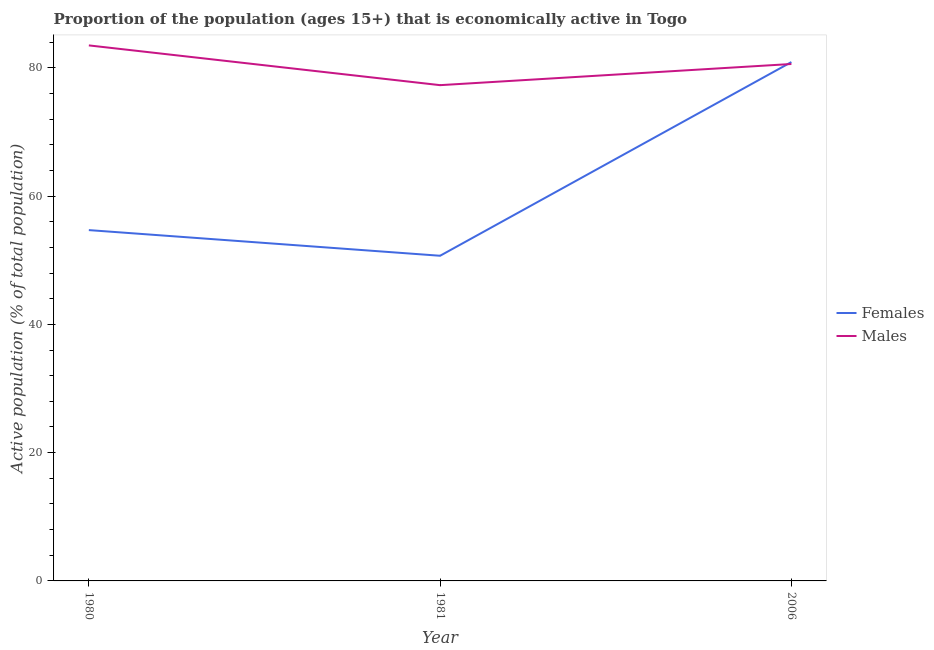Does the line corresponding to percentage of economically active male population intersect with the line corresponding to percentage of economically active female population?
Offer a very short reply. Yes. What is the percentage of economically active female population in 1980?
Your answer should be very brief. 54.7. Across all years, what is the maximum percentage of economically active male population?
Give a very brief answer. 83.5. Across all years, what is the minimum percentage of economically active male population?
Your answer should be compact. 77.3. In which year was the percentage of economically active female population maximum?
Give a very brief answer. 2006. What is the total percentage of economically active male population in the graph?
Your answer should be very brief. 241.4. What is the difference between the percentage of economically active female population in 1980 and the percentage of economically active male population in 1981?
Offer a very short reply. -22.6. What is the average percentage of economically active male population per year?
Keep it short and to the point. 80.47. In the year 1980, what is the difference between the percentage of economically active male population and percentage of economically active female population?
Offer a terse response. 28.8. What is the ratio of the percentage of economically active female population in 1980 to that in 1981?
Keep it short and to the point. 1.08. Is the percentage of economically active female population in 1980 less than that in 1981?
Provide a short and direct response. No. What is the difference between the highest and the second highest percentage of economically active female population?
Ensure brevity in your answer.  26.2. What is the difference between the highest and the lowest percentage of economically active female population?
Provide a succinct answer. 30.2. Is the percentage of economically active female population strictly less than the percentage of economically active male population over the years?
Keep it short and to the point. No. How many lines are there?
Give a very brief answer. 2. How many years are there in the graph?
Give a very brief answer. 3. Where does the legend appear in the graph?
Ensure brevity in your answer.  Center right. How many legend labels are there?
Your answer should be compact. 2. What is the title of the graph?
Your response must be concise. Proportion of the population (ages 15+) that is economically active in Togo. Does "Largest city" appear as one of the legend labels in the graph?
Offer a terse response. No. What is the label or title of the X-axis?
Provide a short and direct response. Year. What is the label or title of the Y-axis?
Provide a succinct answer. Active population (% of total population). What is the Active population (% of total population) of Females in 1980?
Make the answer very short. 54.7. What is the Active population (% of total population) in Males in 1980?
Offer a very short reply. 83.5. What is the Active population (% of total population) in Females in 1981?
Keep it short and to the point. 50.7. What is the Active population (% of total population) of Males in 1981?
Keep it short and to the point. 77.3. What is the Active population (% of total population) in Females in 2006?
Offer a terse response. 80.9. What is the Active population (% of total population) of Males in 2006?
Provide a short and direct response. 80.6. Across all years, what is the maximum Active population (% of total population) of Females?
Your answer should be very brief. 80.9. Across all years, what is the maximum Active population (% of total population) in Males?
Your answer should be very brief. 83.5. Across all years, what is the minimum Active population (% of total population) in Females?
Provide a succinct answer. 50.7. Across all years, what is the minimum Active population (% of total population) of Males?
Keep it short and to the point. 77.3. What is the total Active population (% of total population) of Females in the graph?
Make the answer very short. 186.3. What is the total Active population (% of total population) of Males in the graph?
Offer a terse response. 241.4. What is the difference between the Active population (% of total population) of Females in 1980 and that in 1981?
Keep it short and to the point. 4. What is the difference between the Active population (% of total population) in Males in 1980 and that in 1981?
Your response must be concise. 6.2. What is the difference between the Active population (% of total population) of Females in 1980 and that in 2006?
Ensure brevity in your answer.  -26.2. What is the difference between the Active population (% of total population) in Females in 1981 and that in 2006?
Offer a terse response. -30.2. What is the difference between the Active population (% of total population) in Females in 1980 and the Active population (% of total population) in Males in 1981?
Offer a very short reply. -22.6. What is the difference between the Active population (% of total population) of Females in 1980 and the Active population (% of total population) of Males in 2006?
Provide a short and direct response. -25.9. What is the difference between the Active population (% of total population) in Females in 1981 and the Active population (% of total population) in Males in 2006?
Your answer should be very brief. -29.9. What is the average Active population (% of total population) in Females per year?
Provide a succinct answer. 62.1. What is the average Active population (% of total population) of Males per year?
Offer a very short reply. 80.47. In the year 1980, what is the difference between the Active population (% of total population) in Females and Active population (% of total population) in Males?
Offer a terse response. -28.8. In the year 1981, what is the difference between the Active population (% of total population) of Females and Active population (% of total population) of Males?
Your response must be concise. -26.6. In the year 2006, what is the difference between the Active population (% of total population) of Females and Active population (% of total population) of Males?
Give a very brief answer. 0.3. What is the ratio of the Active population (% of total population) in Females in 1980 to that in 1981?
Your answer should be compact. 1.08. What is the ratio of the Active population (% of total population) in Males in 1980 to that in 1981?
Ensure brevity in your answer.  1.08. What is the ratio of the Active population (% of total population) in Females in 1980 to that in 2006?
Your answer should be very brief. 0.68. What is the ratio of the Active population (% of total population) in Males in 1980 to that in 2006?
Provide a short and direct response. 1.04. What is the ratio of the Active population (% of total population) of Females in 1981 to that in 2006?
Provide a succinct answer. 0.63. What is the ratio of the Active population (% of total population) of Males in 1981 to that in 2006?
Offer a very short reply. 0.96. What is the difference between the highest and the second highest Active population (% of total population) of Females?
Offer a terse response. 26.2. What is the difference between the highest and the lowest Active population (% of total population) of Females?
Provide a short and direct response. 30.2. What is the difference between the highest and the lowest Active population (% of total population) of Males?
Offer a very short reply. 6.2. 